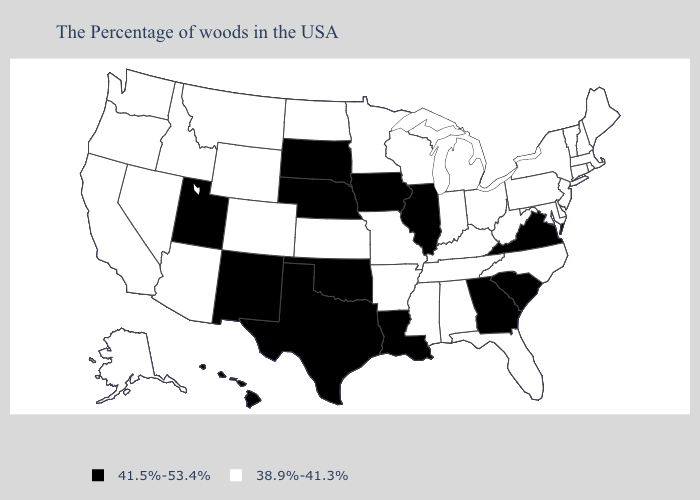Among the states that border Virginia , which have the lowest value?
Keep it brief. Maryland, North Carolina, West Virginia, Kentucky, Tennessee. What is the lowest value in states that border Pennsylvania?
Write a very short answer. 38.9%-41.3%. Does Montana have a higher value than Michigan?
Concise answer only. No. Name the states that have a value in the range 38.9%-41.3%?
Quick response, please. Maine, Massachusetts, Rhode Island, New Hampshire, Vermont, Connecticut, New York, New Jersey, Delaware, Maryland, Pennsylvania, North Carolina, West Virginia, Ohio, Florida, Michigan, Kentucky, Indiana, Alabama, Tennessee, Wisconsin, Mississippi, Missouri, Arkansas, Minnesota, Kansas, North Dakota, Wyoming, Colorado, Montana, Arizona, Idaho, Nevada, California, Washington, Oregon, Alaska. Name the states that have a value in the range 38.9%-41.3%?
Keep it brief. Maine, Massachusetts, Rhode Island, New Hampshire, Vermont, Connecticut, New York, New Jersey, Delaware, Maryland, Pennsylvania, North Carolina, West Virginia, Ohio, Florida, Michigan, Kentucky, Indiana, Alabama, Tennessee, Wisconsin, Mississippi, Missouri, Arkansas, Minnesota, Kansas, North Dakota, Wyoming, Colorado, Montana, Arizona, Idaho, Nevada, California, Washington, Oregon, Alaska. Does the map have missing data?
Concise answer only. No. What is the highest value in the West ?
Quick response, please. 41.5%-53.4%. Is the legend a continuous bar?
Write a very short answer. No. Name the states that have a value in the range 38.9%-41.3%?
Concise answer only. Maine, Massachusetts, Rhode Island, New Hampshire, Vermont, Connecticut, New York, New Jersey, Delaware, Maryland, Pennsylvania, North Carolina, West Virginia, Ohio, Florida, Michigan, Kentucky, Indiana, Alabama, Tennessee, Wisconsin, Mississippi, Missouri, Arkansas, Minnesota, Kansas, North Dakota, Wyoming, Colorado, Montana, Arizona, Idaho, Nevada, California, Washington, Oregon, Alaska. Name the states that have a value in the range 38.9%-41.3%?
Write a very short answer. Maine, Massachusetts, Rhode Island, New Hampshire, Vermont, Connecticut, New York, New Jersey, Delaware, Maryland, Pennsylvania, North Carolina, West Virginia, Ohio, Florida, Michigan, Kentucky, Indiana, Alabama, Tennessee, Wisconsin, Mississippi, Missouri, Arkansas, Minnesota, Kansas, North Dakota, Wyoming, Colorado, Montana, Arizona, Idaho, Nevada, California, Washington, Oregon, Alaska. Among the states that border Utah , which have the lowest value?
Quick response, please. Wyoming, Colorado, Arizona, Idaho, Nevada. Name the states that have a value in the range 38.9%-41.3%?
Answer briefly. Maine, Massachusetts, Rhode Island, New Hampshire, Vermont, Connecticut, New York, New Jersey, Delaware, Maryland, Pennsylvania, North Carolina, West Virginia, Ohio, Florida, Michigan, Kentucky, Indiana, Alabama, Tennessee, Wisconsin, Mississippi, Missouri, Arkansas, Minnesota, Kansas, North Dakota, Wyoming, Colorado, Montana, Arizona, Idaho, Nevada, California, Washington, Oregon, Alaska. What is the value of Georgia?
Short answer required. 41.5%-53.4%. Does the map have missing data?
Keep it brief. No. 